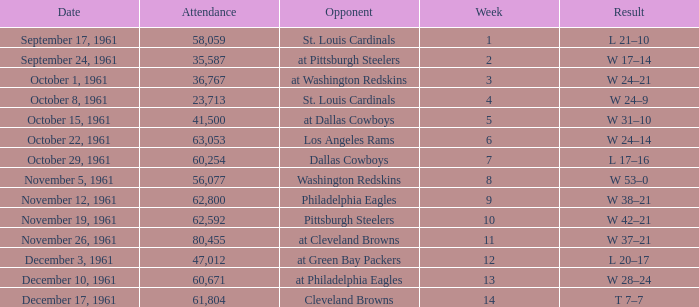Which Attendance has a Date of november 19, 1961? 62592.0. 